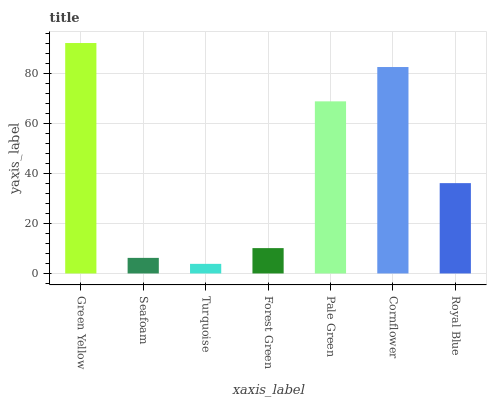Is Turquoise the minimum?
Answer yes or no. Yes. Is Green Yellow the maximum?
Answer yes or no. Yes. Is Seafoam the minimum?
Answer yes or no. No. Is Seafoam the maximum?
Answer yes or no. No. Is Green Yellow greater than Seafoam?
Answer yes or no. Yes. Is Seafoam less than Green Yellow?
Answer yes or no. Yes. Is Seafoam greater than Green Yellow?
Answer yes or no. No. Is Green Yellow less than Seafoam?
Answer yes or no. No. Is Royal Blue the high median?
Answer yes or no. Yes. Is Royal Blue the low median?
Answer yes or no. Yes. Is Seafoam the high median?
Answer yes or no. No. Is Seafoam the low median?
Answer yes or no. No. 